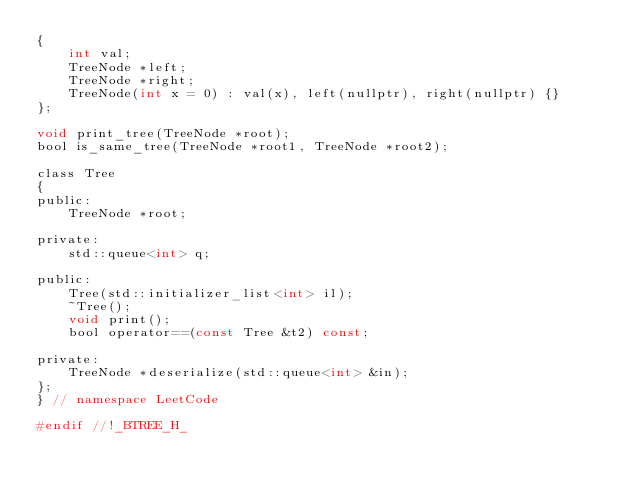<code> <loc_0><loc_0><loc_500><loc_500><_C_>{
    int val;
    TreeNode *left;
    TreeNode *right;
    TreeNode(int x = 0) : val(x), left(nullptr), right(nullptr) {}
};

void print_tree(TreeNode *root);
bool is_same_tree(TreeNode *root1, TreeNode *root2);

class Tree
{
public:
    TreeNode *root;

private:
    std::queue<int> q;

public:
    Tree(std::initializer_list<int> il);
    ~Tree();
    void print();
    bool operator==(const Tree &t2) const;

private:
    TreeNode *deserialize(std::queue<int> &in);
};
} // namespace LeetCode

#endif //!_BTREE_H_</code> 